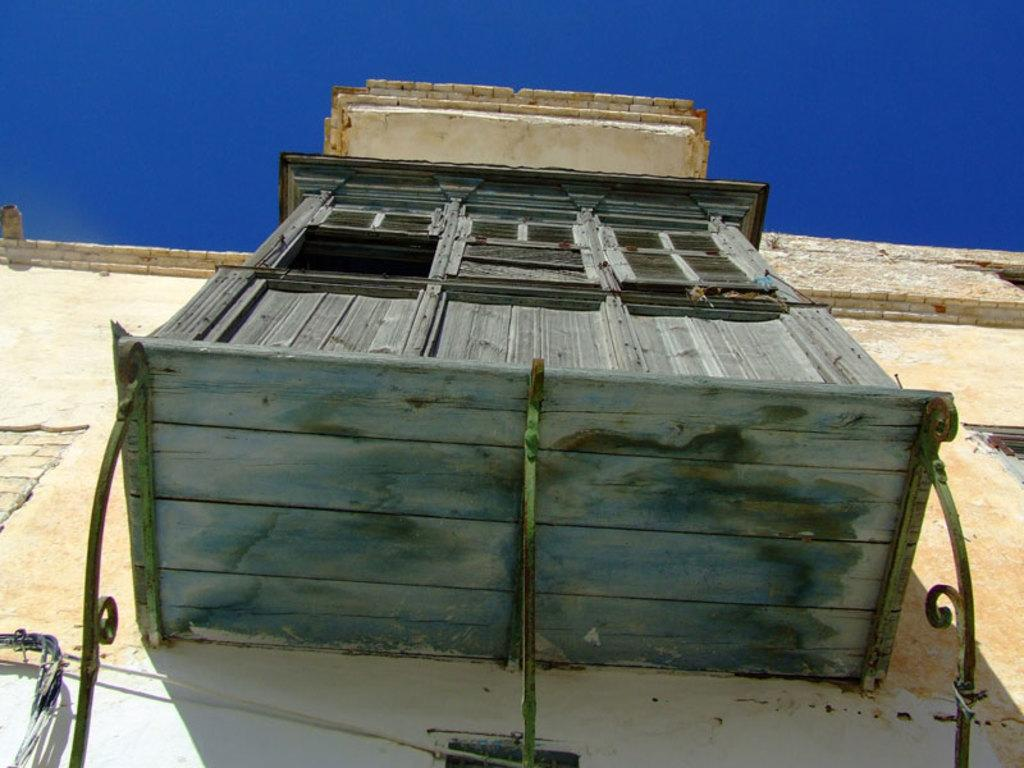What is the main subject of the image? The main subject of the image is a building. What specific features can be observed on the building? The building has windows. What else can be seen in the image besides the building? The sky is visible in the image. What thought is being expressed by the mine in the image? There is no mine present in the image, and therefore no thoughts can be attributed to it. 